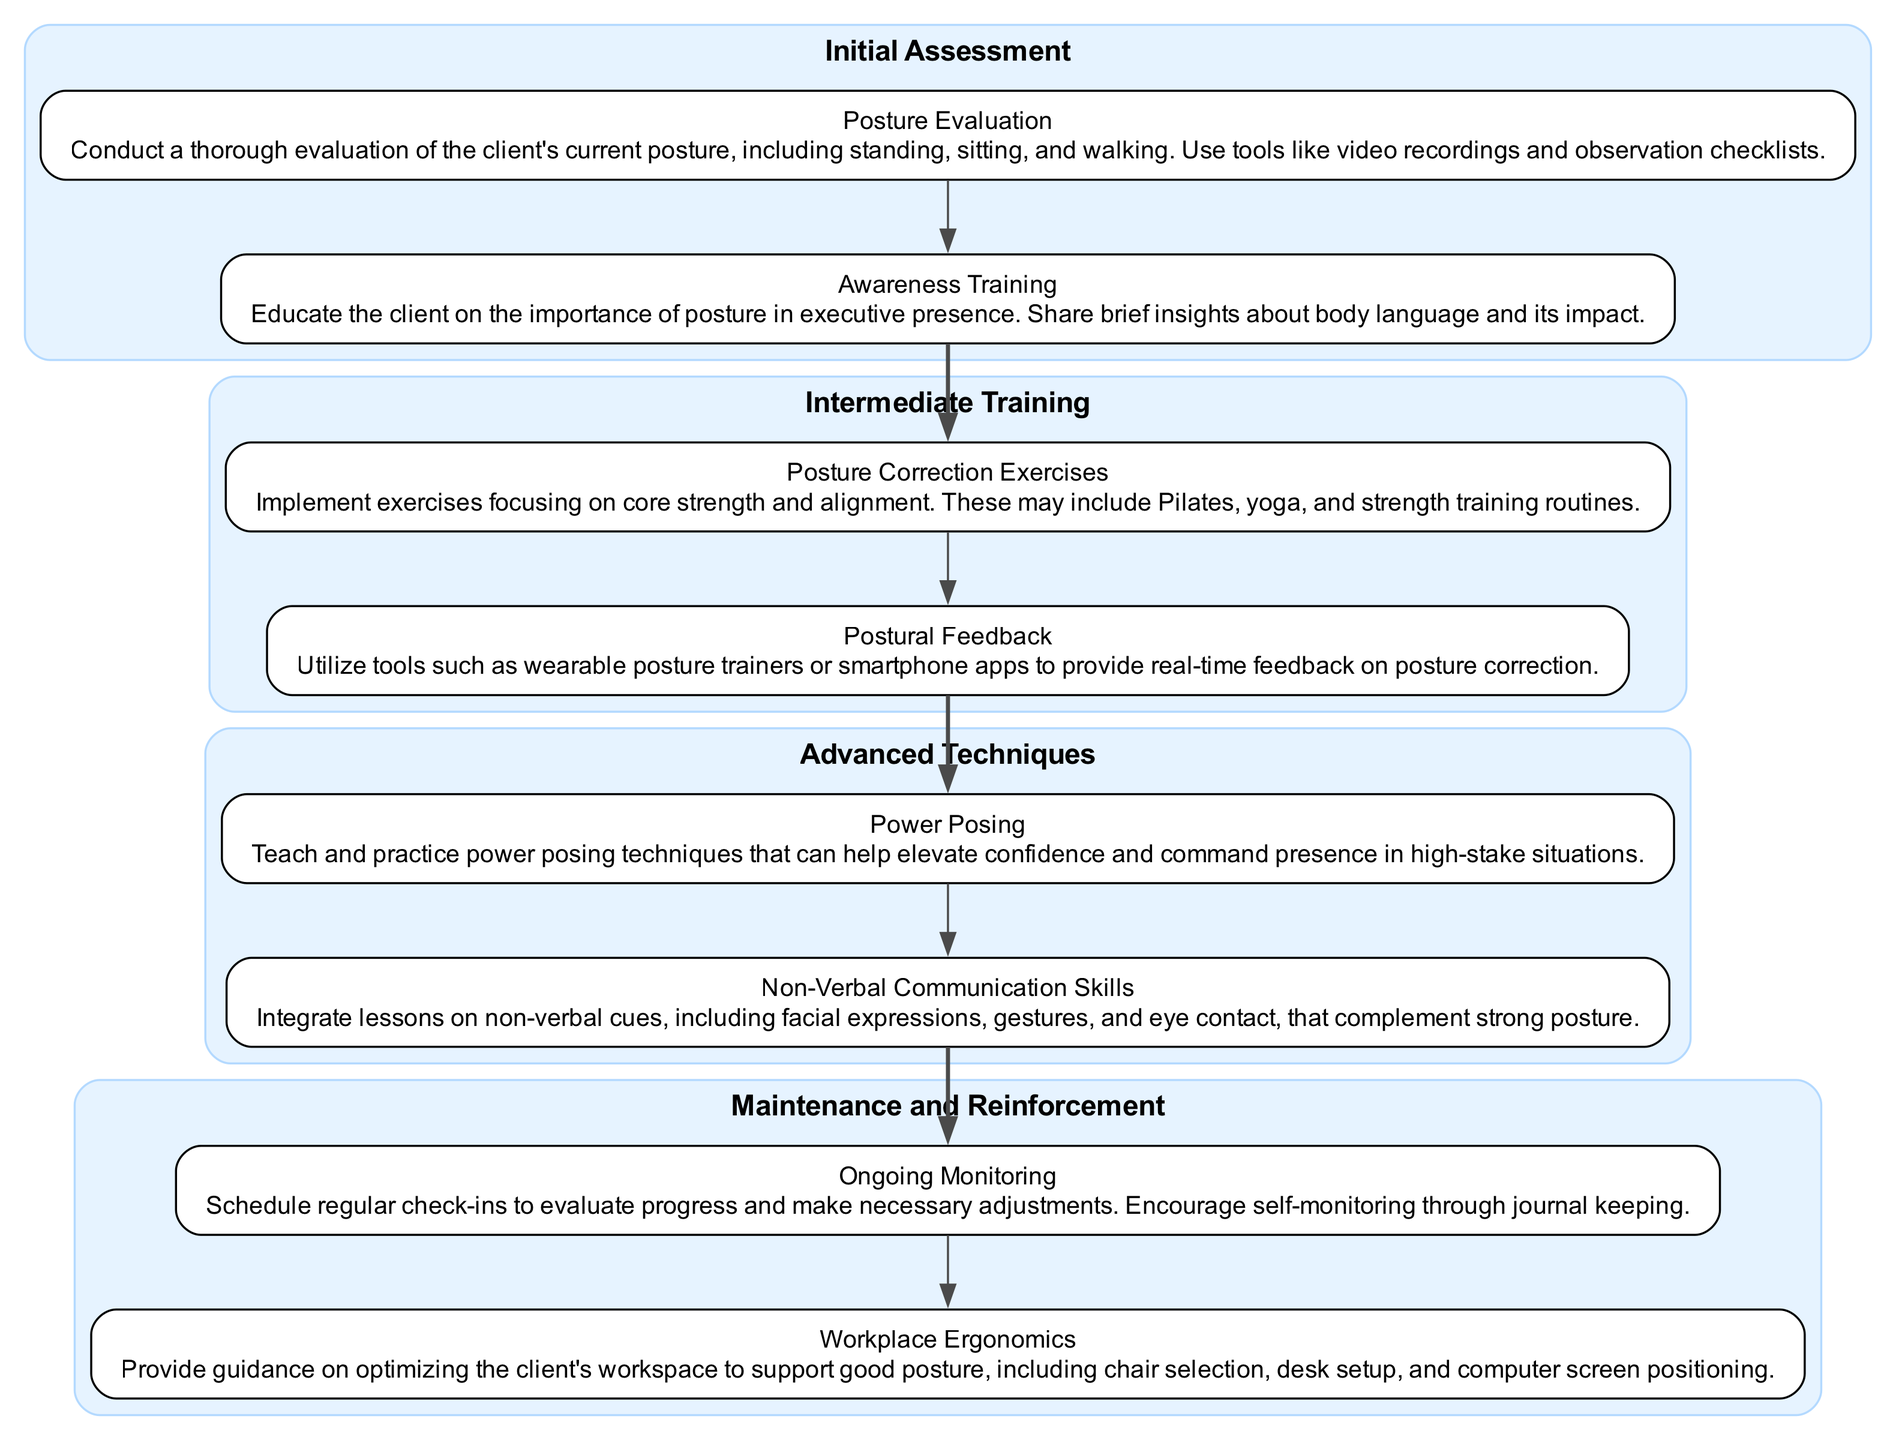What are the stages in the clinical pathway? The diagram clearly lists four stages: Initial Assessment, Intermediate Training, Advanced Techniques, and Maintenance and Reinforcement. These stages are visually separated and grouped, allowing for easy identification.
Answer: Initial Assessment, Intermediate Training, Advanced Techniques, Maintenance and Reinforcement How many tasks are in the Intermediate Training stage? Upon examining the Intermediate Training stage, it contains two tasks: Posture Correction Exercises and Postural Feedback. This is confirmed by the number of task nodes within that stage.
Answer: 2 What task follows Postural Feedback? Looking at the Intermediate Training stage, Postural Feedback is the second task. The next stage directly following it is Advanced Techniques, where the first task is Power Posing.
Answer: Power Posing Which stage includes the task "Awareness Training"? The task "Awareness Training" is listed under the Initial Assessment stage, as seen at the beginning of the pathway. The task's presence in the task list confirms its placement.
Answer: Initial Assessment How many total tasks are there in the clinical pathway? By counting all the tasks from each stage, there are a total of eight tasks across the four stages: two in Initial Assessment, two in Intermediate Training, two in Advanced Techniques, and two in Maintenance and Reinforcement.
Answer: 8 What is the focus of the Advanced Techniques stage? The Advanced Techniques stage focuses on two key tasks — Power Posing and Non-Verbal Communication Skills. This indicates an emphasis on enhancing executive presence through elevated confidence and effective body language.
Answer: Power Posing, Non-Verbal Communication Skills How does the Maintenance and Reinforcement stage support ongoing progress? The Maintenance and Reinforcement stage includes tasks such as Ongoing Monitoring and Workplace Ergonomics. These tasks help reinforce the skills acquired and ensure support for maintaining good posture.
Answer: Ongoing Monitoring, Workplace Ergonomics Which task is the first in the Maintenance and Reinforcement stage? In the Maintenance and Reinforcement stage, the first task listed is Ongoing Monitoring, indicating that this is the initial focus of maintaining progress.
Answer: Ongoing Monitoring 